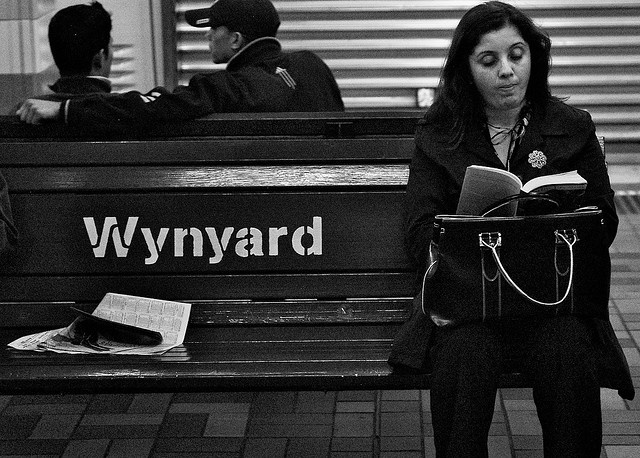Describe the objects in this image and their specific colors. I can see bench in darkgray, black, gray, and lightgray tones, people in darkgray, black, gray, and lightgray tones, handbag in darkgray, black, gray, and white tones, people in darkgray, black, gray, and lightgray tones, and bench in black, gray, and darkgray tones in this image. 